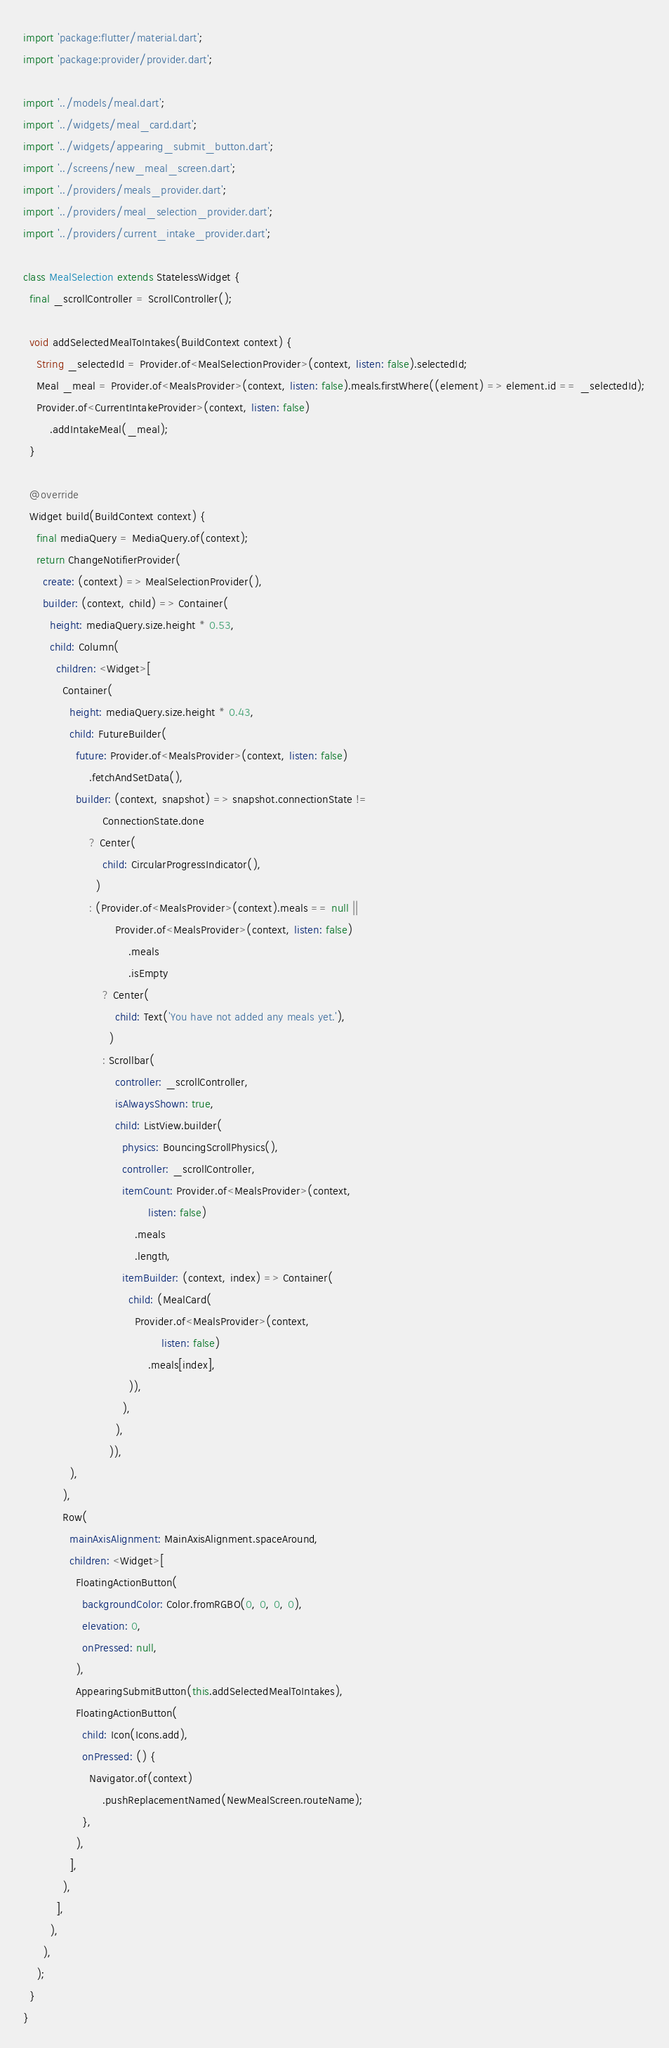Convert code to text. <code><loc_0><loc_0><loc_500><loc_500><_Dart_>import 'package:flutter/material.dart';
import 'package:provider/provider.dart';

import '../models/meal.dart';
import '../widgets/meal_card.dart';
import '../widgets/appearing_submit_button.dart';
import '../screens/new_meal_screen.dart';
import '../providers/meals_provider.dart';
import '../providers/meal_selection_provider.dart';
import '../providers/current_intake_provider.dart';

class MealSelection extends StatelessWidget {
  final _scrollController = ScrollController();

  void addSelectedMealToIntakes(BuildContext context) {
    String _selectedId = Provider.of<MealSelectionProvider>(context, listen: false).selectedId;
    Meal _meal = Provider.of<MealsProvider>(context, listen: false).meals.firstWhere((element) => element.id == _selectedId);
    Provider.of<CurrentIntakeProvider>(context, listen: false)
        .addIntakeMeal(_meal);
  }

  @override
  Widget build(BuildContext context) {
    final mediaQuery = MediaQuery.of(context);
    return ChangeNotifierProvider(
      create: (context) => MealSelectionProvider(),
      builder: (context, child) => Container(
        height: mediaQuery.size.height * 0.53,
        child: Column(
          children: <Widget>[
            Container(
              height: mediaQuery.size.height * 0.43,
              child: FutureBuilder(
                future: Provider.of<MealsProvider>(context, listen: false)
                    .fetchAndSetData(),
                builder: (context, snapshot) => snapshot.connectionState !=
                        ConnectionState.done
                    ? Center(
                        child: CircularProgressIndicator(),
                      )
                    : (Provider.of<MealsProvider>(context).meals == null ||
                            Provider.of<MealsProvider>(context, listen: false)
                                .meals
                                .isEmpty
                        ? Center(
                            child: Text('You have not added any meals yet.'),
                          )
                        : Scrollbar(
                            controller: _scrollController,
                            isAlwaysShown: true,
                            child: ListView.builder(
                              physics: BouncingScrollPhysics(),
                              controller: _scrollController,
                              itemCount: Provider.of<MealsProvider>(context,
                                      listen: false)
                                  .meals
                                  .length,
                              itemBuilder: (context, index) => Container(
                                child: (MealCard(
                                  Provider.of<MealsProvider>(context,
                                          listen: false)
                                      .meals[index],
                                )),
                              ),
                            ),
                          )),
              ),
            ),
            Row(
              mainAxisAlignment: MainAxisAlignment.spaceAround,
              children: <Widget>[
                FloatingActionButton(
                  backgroundColor: Color.fromRGBO(0, 0, 0, 0),
                  elevation: 0,
                  onPressed: null,
                ),
                AppearingSubmitButton(this.addSelectedMealToIntakes),
                FloatingActionButton(
                  child: Icon(Icons.add),
                  onPressed: () {
                    Navigator.of(context)
                        .pushReplacementNamed(NewMealScreen.routeName);
                  },
                ),
              ],
            ),
          ],
        ),
      ),
    );
  }
}
</code> 